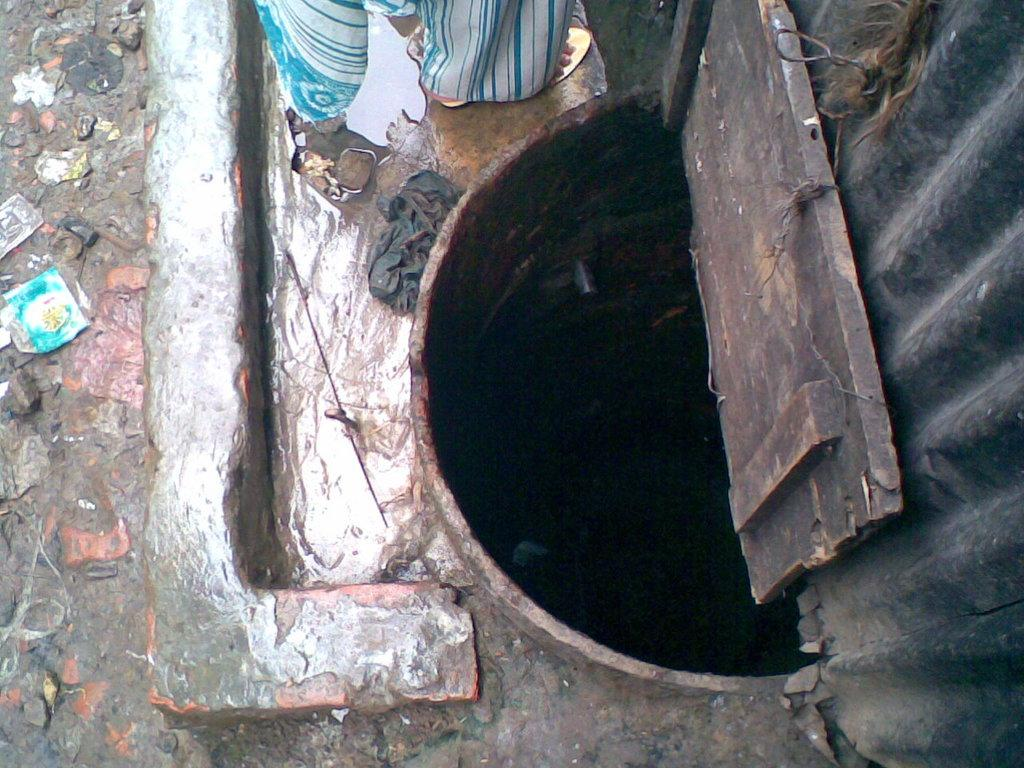What is the main structure in the image? There is a well in the image. What is the state of the well? The well is open. Where is the well located in relation to other structures? The well is near a wall. What is the person in the image doing? There is a person on the floor in the image. What can be seen on the left side of the image? There are covers on the road on the left side of the image. How many ladybugs can be seen crawling on the crown in the image? There are no ladybugs or crowns present in the image. 